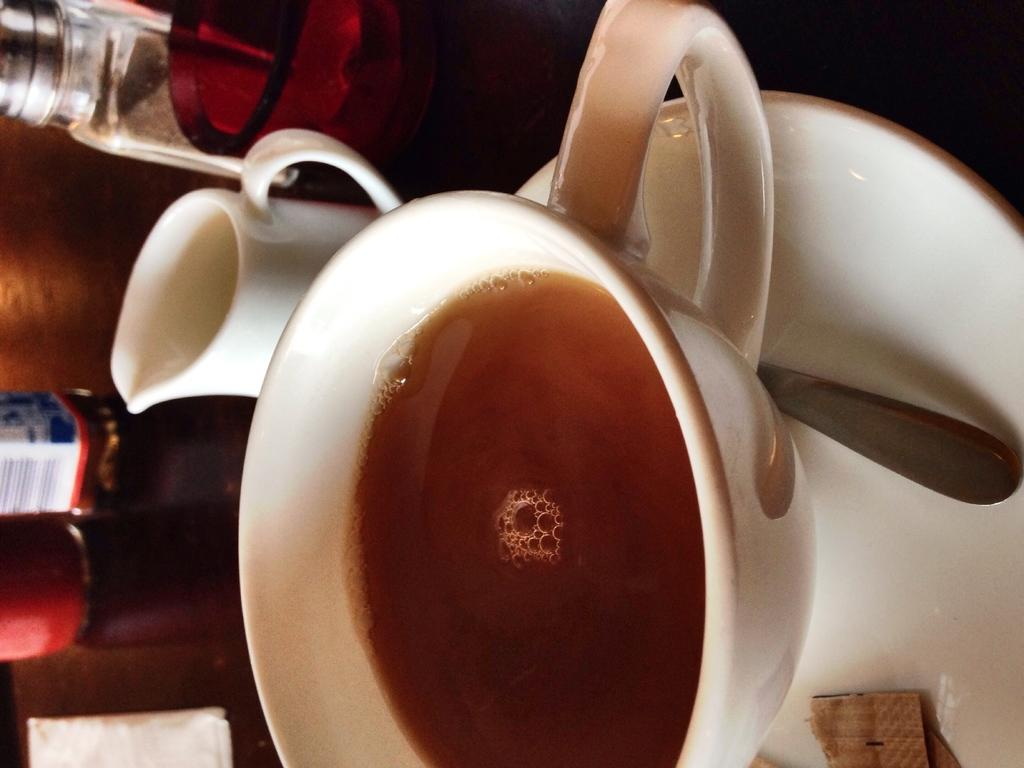What objects can be seen on the table in the image? There are cups, a saucer, a spoon, and bottles on the table. What might be used for stirring or scooping in the image? The spoon on the table can be used for stirring or scooping. What is in one of the cups on the table? There is a drink in a cup on the table. What other items are present on the table that are not mentioned specifically? There are other things on the table, but their exact nature is not specified. What type of breakfast is being served on the sheet in the image? There is no sheet or breakfast present in the image; it only shows objects on a table. Is there a fireman present in the image? There is no fireman present in the image; it only shows objects on a table. 